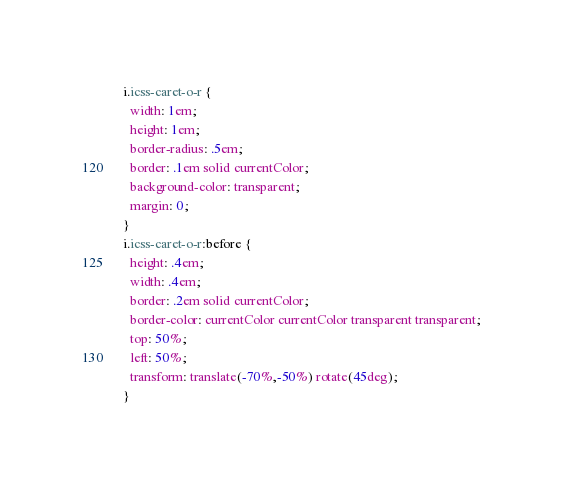Convert code to text. <code><loc_0><loc_0><loc_500><loc_500><_CSS_>i.icss-caret-o-r {
  width: 1em;
  height: 1em;
  border-radius: .5em;
  border: .1em solid currentColor;
  background-color: transparent;
  margin: 0;
}
i.icss-caret-o-r:before {
  height: .4em;
  width: .4em;
  border: .2em solid currentColor;
  border-color: currentColor currentColor transparent transparent;
  top: 50%;
  left: 50%;
  transform: translate(-70%,-50%) rotate(45deg);
}
</code> 